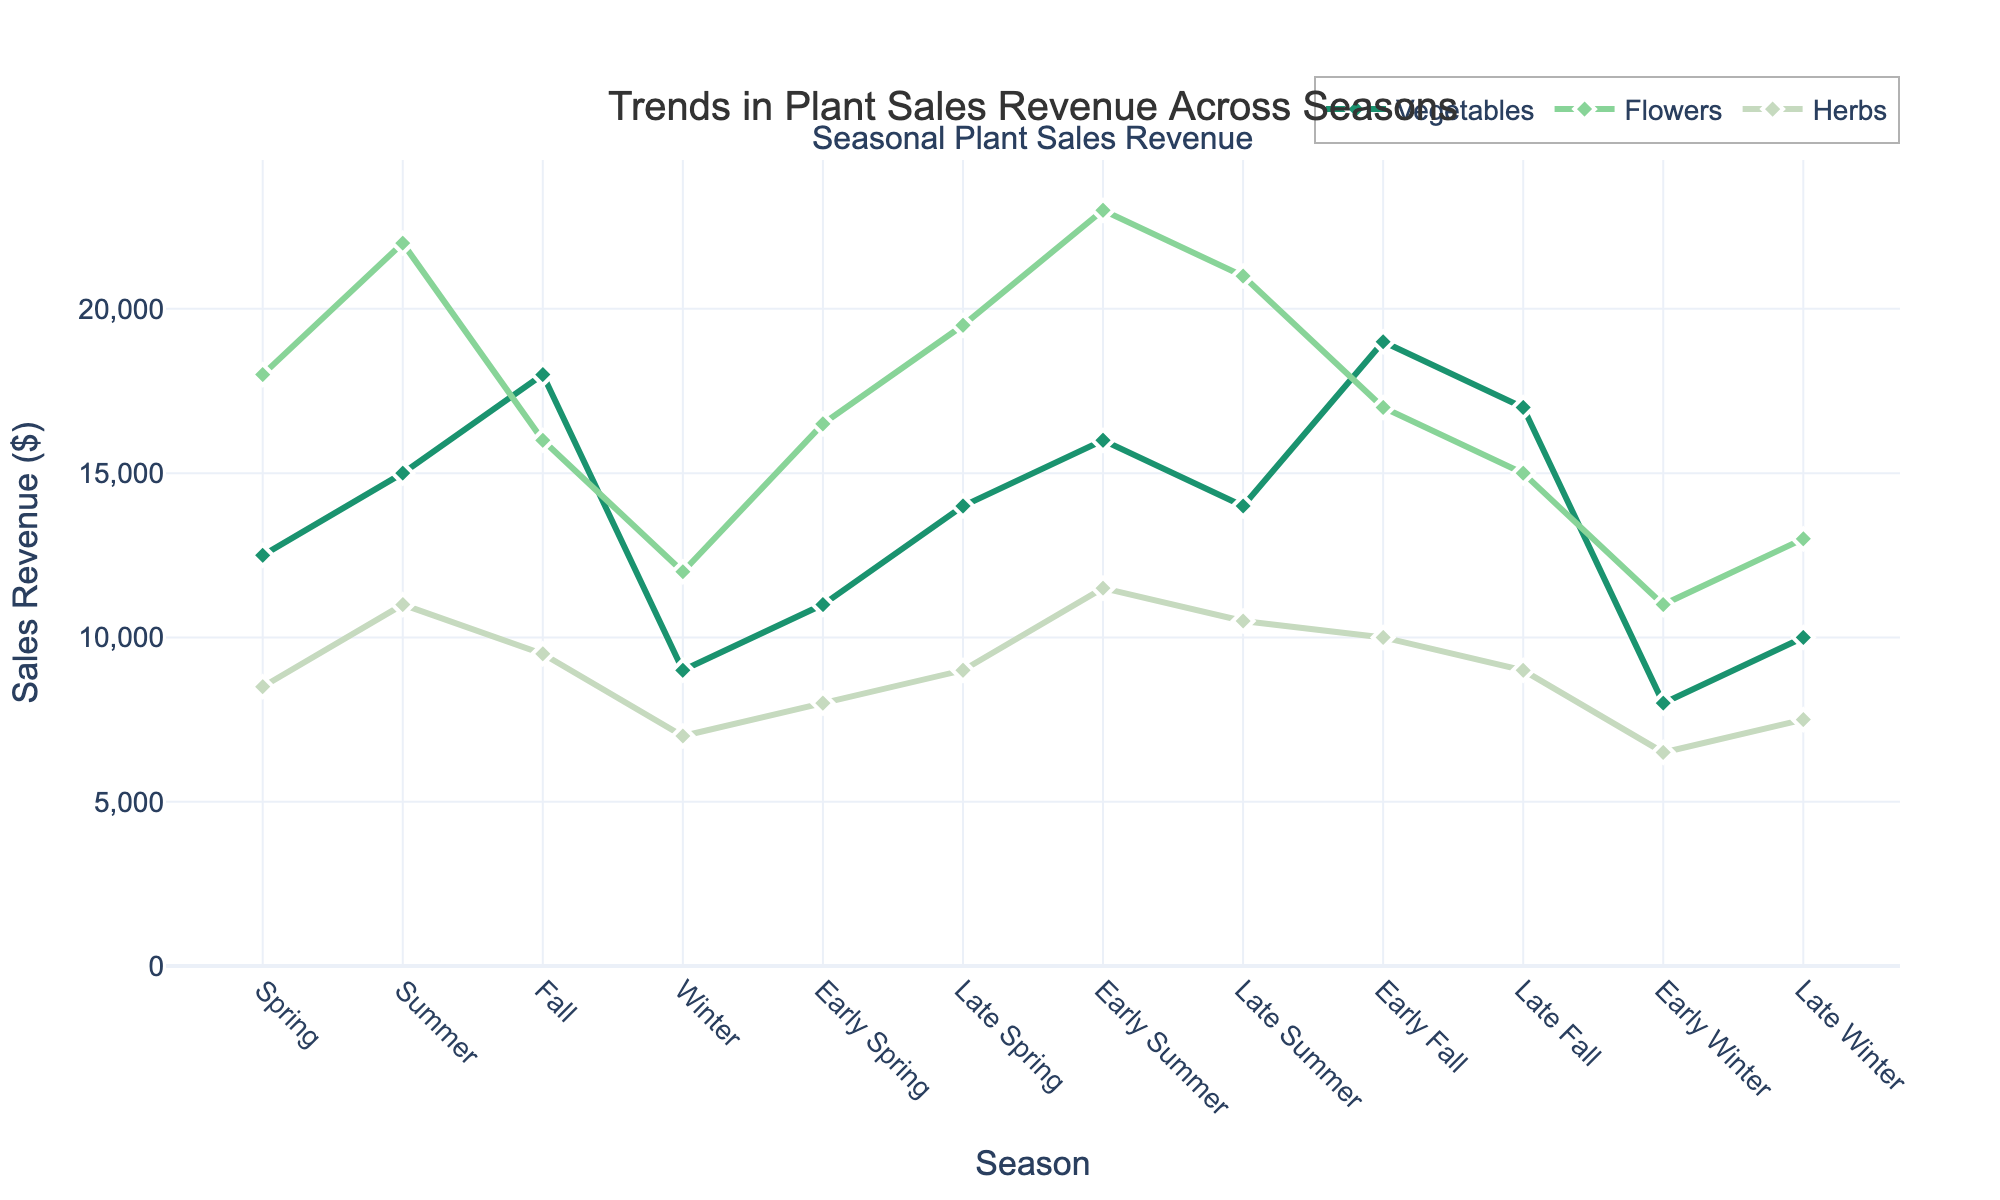How does sales revenue for vegetables change from Spring to Fall? To answer this question, find the sales revenue for vegetables in Spring and Fall from the chart. For Spring, it's $12,500; for Fall, it's $18,000. Calculate the difference: $18,000 - $12,500 = $5,500. Therefore, the sales revenue for vegetables increases by $5,500 from Spring to Fall.
Answer: Increases by $5,500 Which type of plant has the highest sales revenue in Early Summer? Refer to the chart to find the sales revenue for each plant type in Early Summer. Vegetables have $16,000, Flowers have $23,000, and Herbs have $11,500. Among these, Flowers have the highest revenue of $23,000.
Answer: Flowers What is the average sales revenue for Herbs across all seasons? The sales revenue for Herbs across all seasons is: 8500, 11000, 9500, 7000, 8000, 9000, 11500, 10500, 10000, 9000, 6500, and 7500. Sum these values: 8500 + 11000 + 9500 + 7000 + 8000 + 9000 + 11500 + 10500 + 10000 + 9000 + 6500 + 7500 = 119000. Divide by the number of seasons (12): 119000 / 12 = 9916.67.
Answer: 9916.67 Which season sees the sharpest decline in sales revenue for Flowers? Identify the seasons with the largest drop between them for Flowers. The greatest drop is from Early Summer ($23,000) to Late Summer ($21,000), which is a decline of $2,000.
Answer: Early Summer to Late Summer What is the total sales revenue for all plant types in Winter? Sum the sales revenue for Vegetables, Flowers, and Herbs in Winter. Vegetables: $9,000, Flowers: $12,000, Herbs: $7,000. Total: 9000 + 12000 + 7000 = 28000.
Answer: $28,000 Between which two seasons does the sales revenue for Vegetables increase the most? Compare the differences in sales between consecutive seasons for Vegetables and identify the largest increase. The highest increase is from Fall ($18,000) to Early Fall ($19,000), which is an increase of $1,000.
Answer: Fall to Early Fall What is the pattern of sales revenue for Herbs across the Winter season (Early Winter and Late Winter)? Check the sales revenue for Herbs in Early Winter and Late Winter and observe the trend. Early Winter: $6,500, Late Winter: $7,500. This shows an increase of $1,000.
Answer: Increases by $1,000 Which plant type has the least fluctuation in sales revenue across seasons? Compare the variation range (maximum value - minimum value) for each plant type. Vegetables range from $8,000 to $19,000, Flowers range from $11,000 to $23,000, Herbs range from $6,500 to $11,500. Herbs have the smallest range (5,000).
Answer: Herbs 